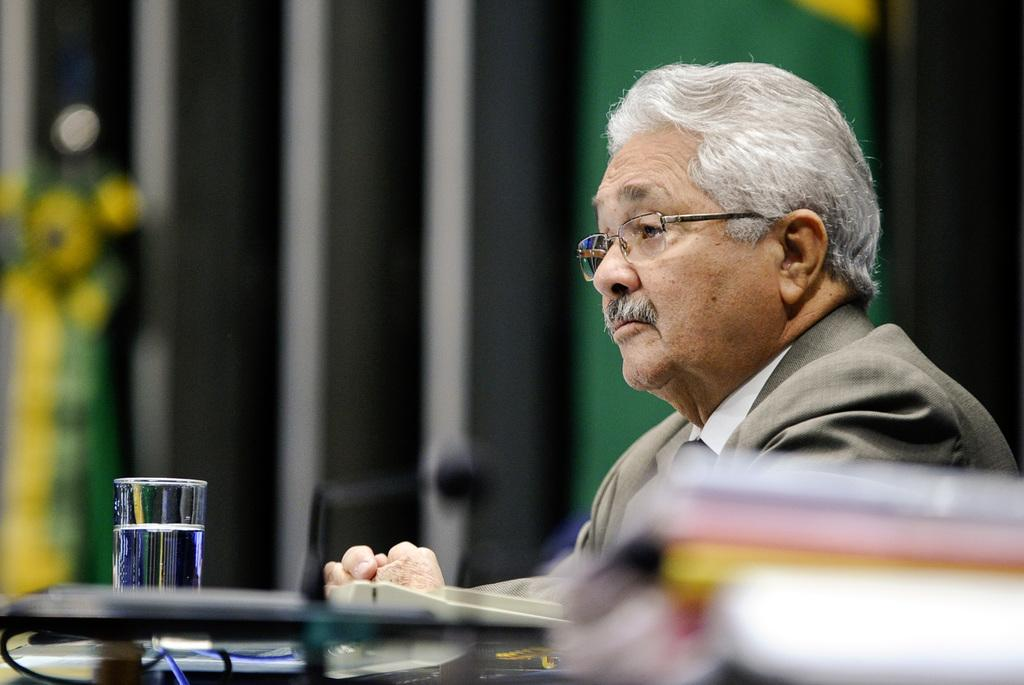Who is present in the image? There is a man in the image. What is the man holding in the image? The man is holding a glass filled with water. Can you describe the background of the man in the image? The background of the man is blurred. What type of cheese is the man eating in the image? There is no cheese present in the image; the man is holding a glass filled with water. What is the relation between the man and the person standing next to him in the image? There is no other person present in the image; the man is alone. 